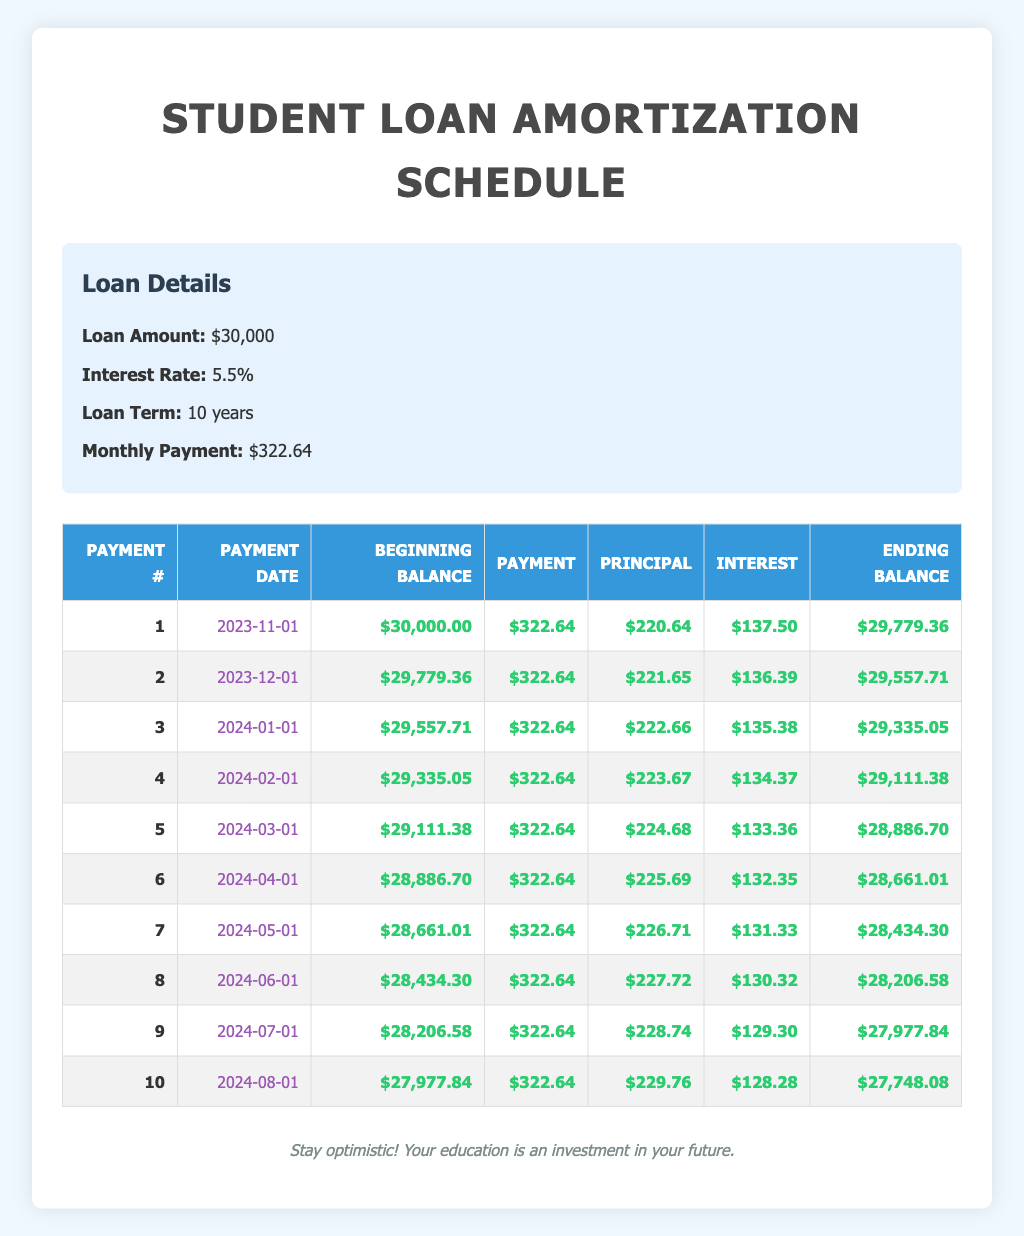What is the monthly payment for the loan? The table shows the loan details, and it specifies that the monthly payment is listed as $322.64.
Answer: 322.64 What was the interest paid in the first payment? In the first payment, the table indicates that the interest amount is $137.50.
Answer: 137.50 What is the ending balance after the 5th payment? The table lists the ending balance after the 5th payment as $28,886.70.
Answer: 28886.70 How much principal is paid in the 3rd payment? According to the table, the principal paid in the 3rd payment is $222.66.
Answer: 222.66 Is the interest payment decreasing with each payment? By comparing the interest columns for each payment, it can be seen that the interest payment starts at $137.50 and decreases with each subsequent payment.
Answer: Yes What is the total amount of interest paid after the first 4 payments? To calculate this, sum the interest paid for the first four payments: $137.50 + $136.39 + $135.38 + $134.37 = $543.64. Therefore, the total interest paid after the first 4 payments is $543.64.
Answer: 543.64 What was the beginning balance for the 6th payment? The beginning balance for the 6th payment can be found in the table, and it shows a beginning balance of $28,886.70.
Answer: 28886.70 Is the monthly payment consistent throughout the payments? The table indicates that every monthly payment is fixed at $322.64 and does not change across the 10 payments.
Answer: Yes What is the difference between the principal paid in the 2nd and 4th payments? The principal for the 2nd payment is $221.65 and for the 4th payment it is $223.67. Thus, the difference is $223.67 - $221.65 = $2.02.
Answer: 2.02 What will be the ending balance after the 10th payment? After the 10th payment, the table shows an ending balance of $27,748.08.
Answer: 27748.08 